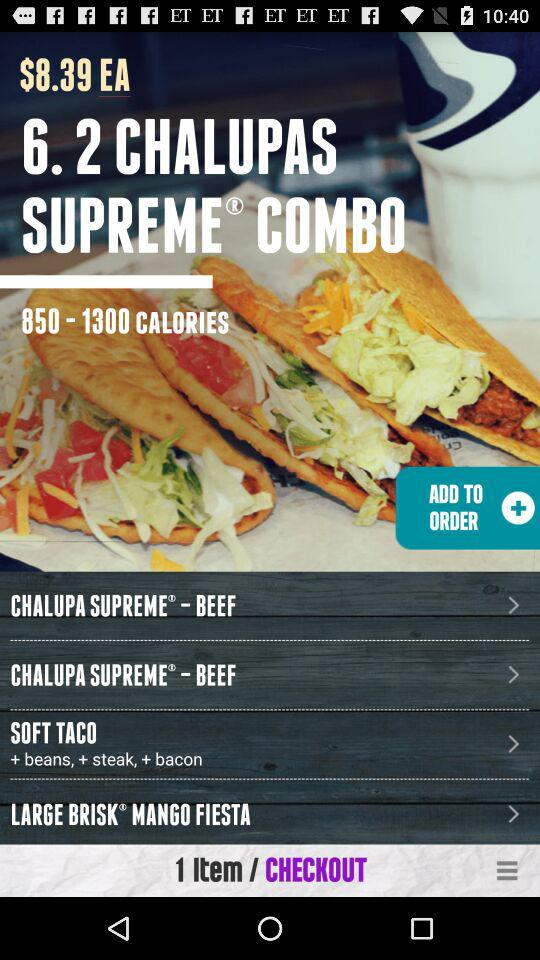How many items are in my cart?
Answer the question using a single word or phrase. 1 